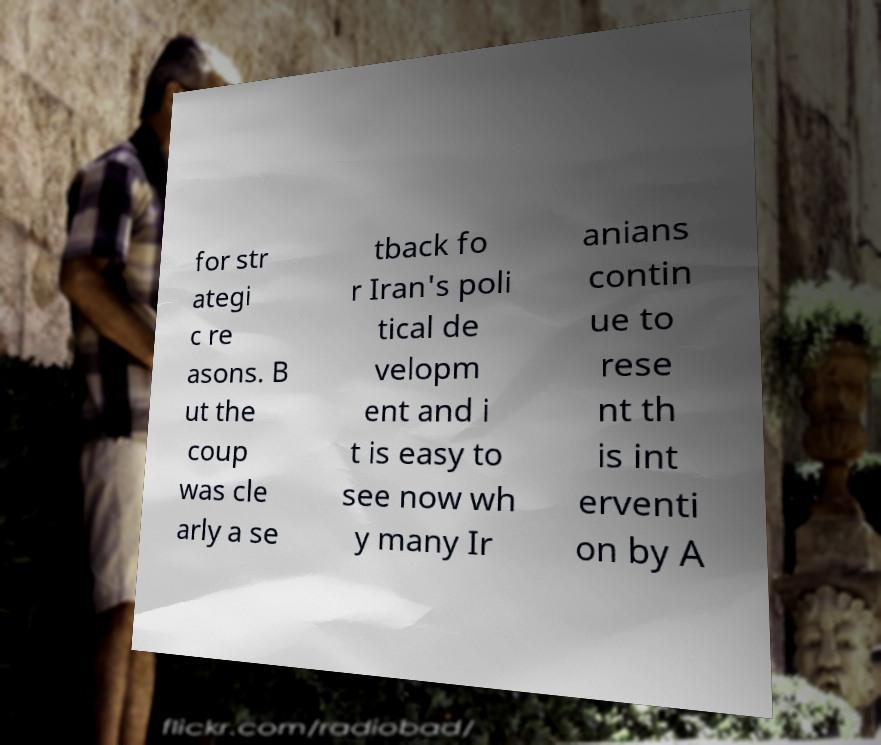Please read and relay the text visible in this image. What does it say? for str ategi c re asons. B ut the coup was cle arly a se tback fo r Iran's poli tical de velopm ent and i t is easy to see now wh y many Ir anians contin ue to rese nt th is int erventi on by A 